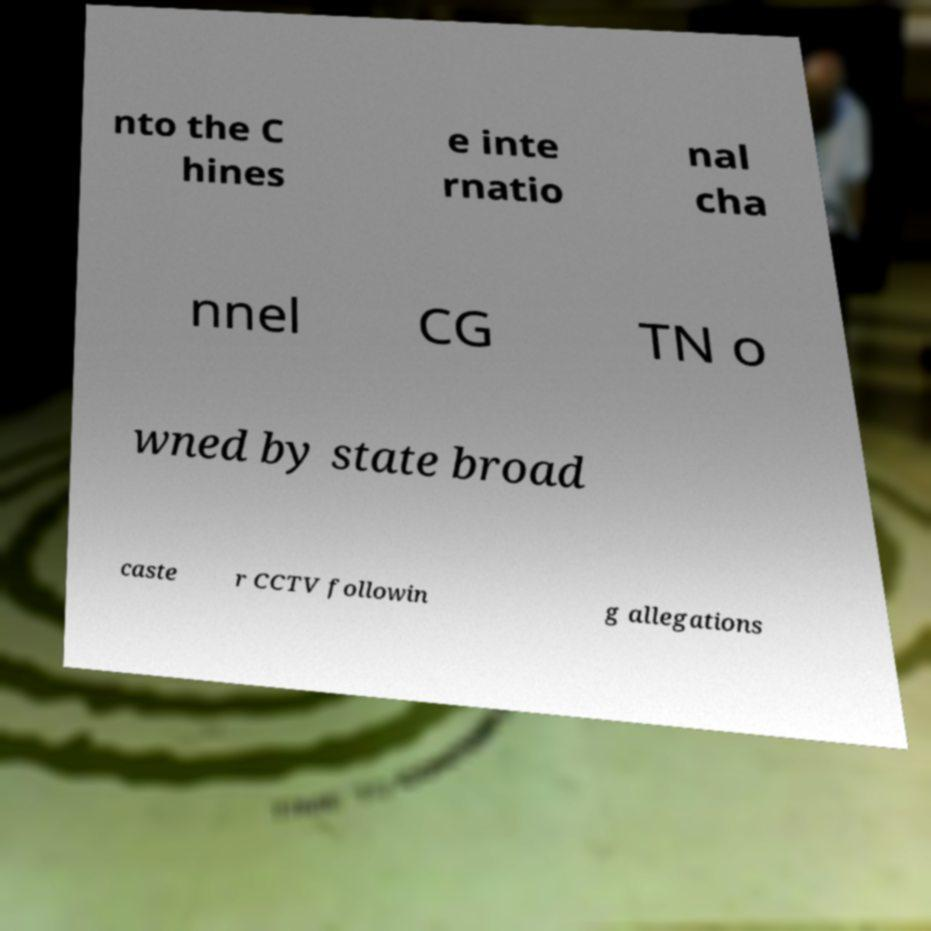What messages or text are displayed in this image? I need them in a readable, typed format. nto the C hines e inte rnatio nal cha nnel CG TN o wned by state broad caste r CCTV followin g allegations 